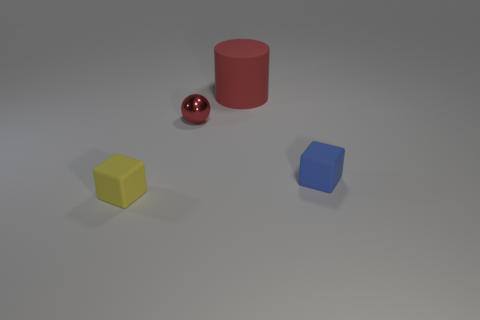What number of red metallic balls are there? There is one red metallic ball present in the image, which has a shiny surface that reflects the light and stands out among the other objects. 